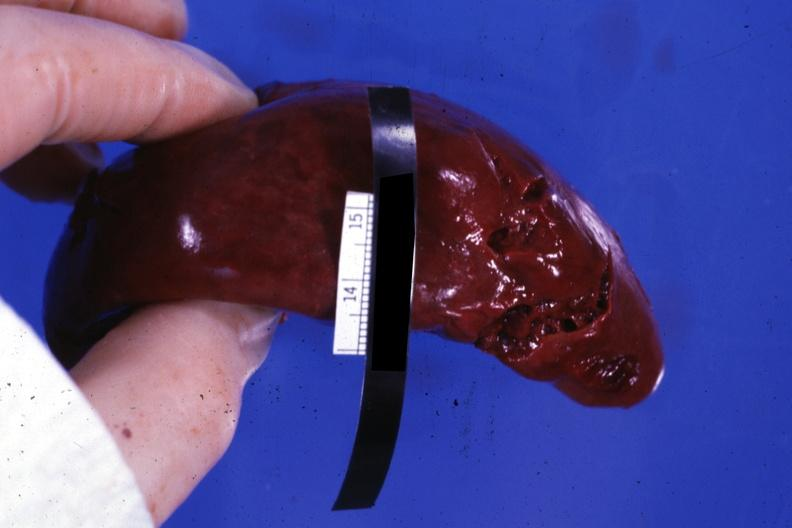what is present?
Answer the question using a single word or phrase. Spleen 